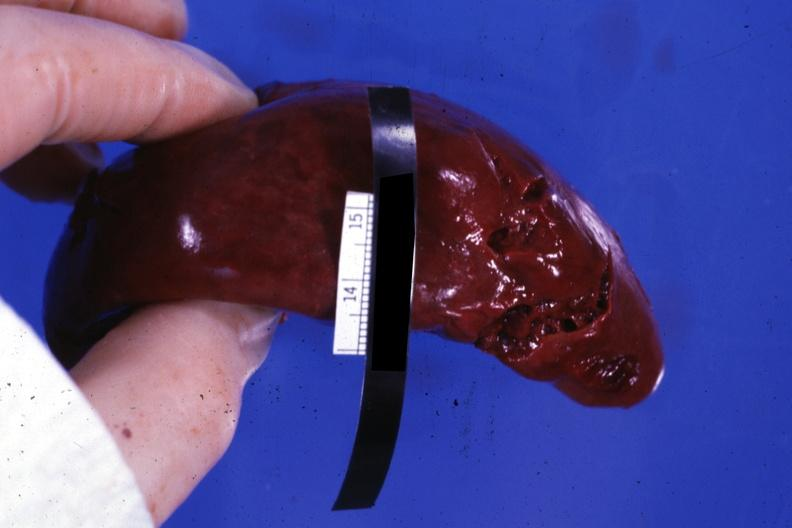what is present?
Answer the question using a single word or phrase. Spleen 